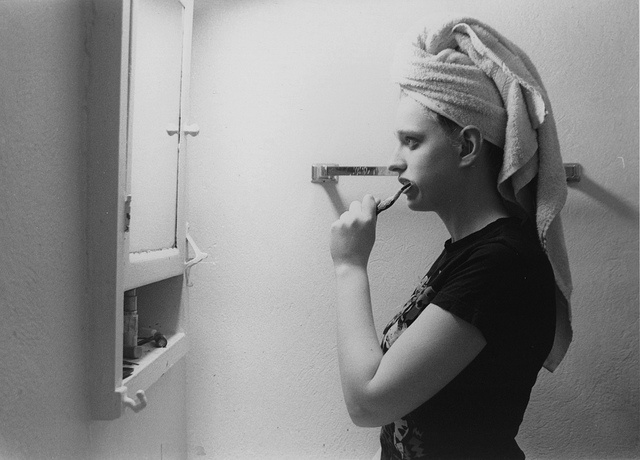Describe the objects in this image and their specific colors. I can see people in darkgray, black, gray, and lightgray tones, bottle in black, gray, and darkgray tones, and toothbrush in darkgray, black, gray, and lightgray tones in this image. 